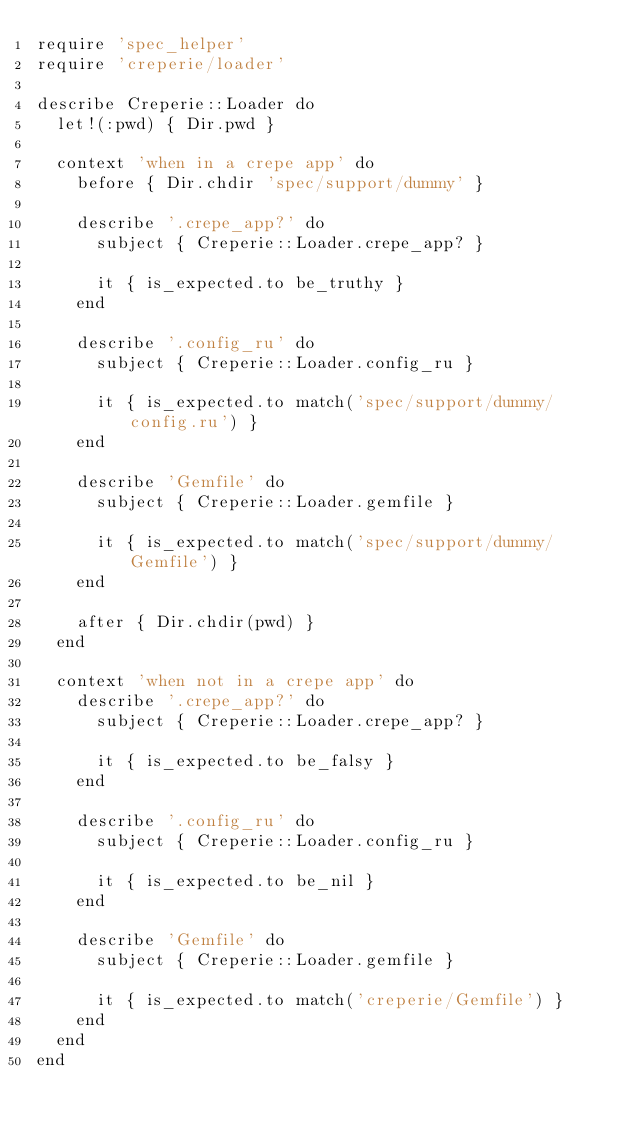<code> <loc_0><loc_0><loc_500><loc_500><_Ruby_>require 'spec_helper'
require 'creperie/loader'

describe Creperie::Loader do
  let!(:pwd) { Dir.pwd }

  context 'when in a crepe app' do
    before { Dir.chdir 'spec/support/dummy' }

    describe '.crepe_app?' do
      subject { Creperie::Loader.crepe_app? }

      it { is_expected.to be_truthy }
    end

    describe '.config_ru' do
      subject { Creperie::Loader.config_ru }

      it { is_expected.to match('spec/support/dummy/config.ru') }
    end

    describe 'Gemfile' do
      subject { Creperie::Loader.gemfile }

      it { is_expected.to match('spec/support/dummy/Gemfile') }
    end

    after { Dir.chdir(pwd) }
  end

  context 'when not in a crepe app' do
    describe '.crepe_app?' do
      subject { Creperie::Loader.crepe_app? }

      it { is_expected.to be_falsy }
    end

    describe '.config_ru' do
      subject { Creperie::Loader.config_ru }

      it { is_expected.to be_nil }
    end

    describe 'Gemfile' do
      subject { Creperie::Loader.gemfile }

      it { is_expected.to match('creperie/Gemfile') }
    end
  end
end
</code> 